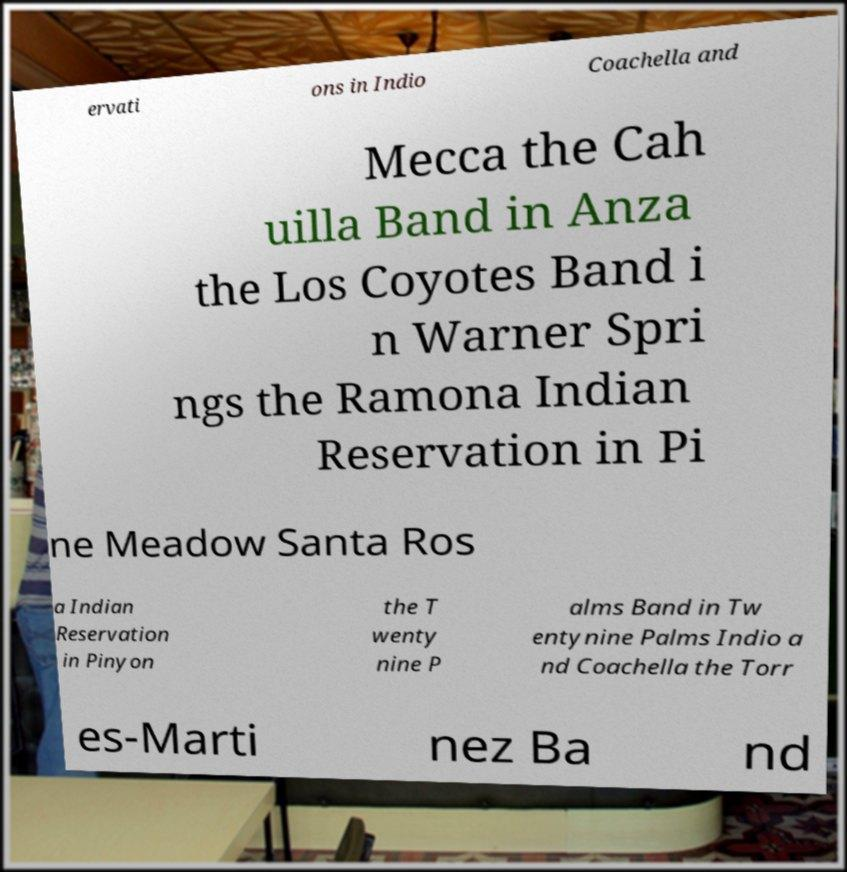I need the written content from this picture converted into text. Can you do that? ervati ons in Indio Coachella and Mecca the Cah uilla Band in Anza the Los Coyotes Band i n Warner Spri ngs the Ramona Indian Reservation in Pi ne Meadow Santa Ros a Indian Reservation in Pinyon the T wenty nine P alms Band in Tw entynine Palms Indio a nd Coachella the Torr es-Marti nez Ba nd 